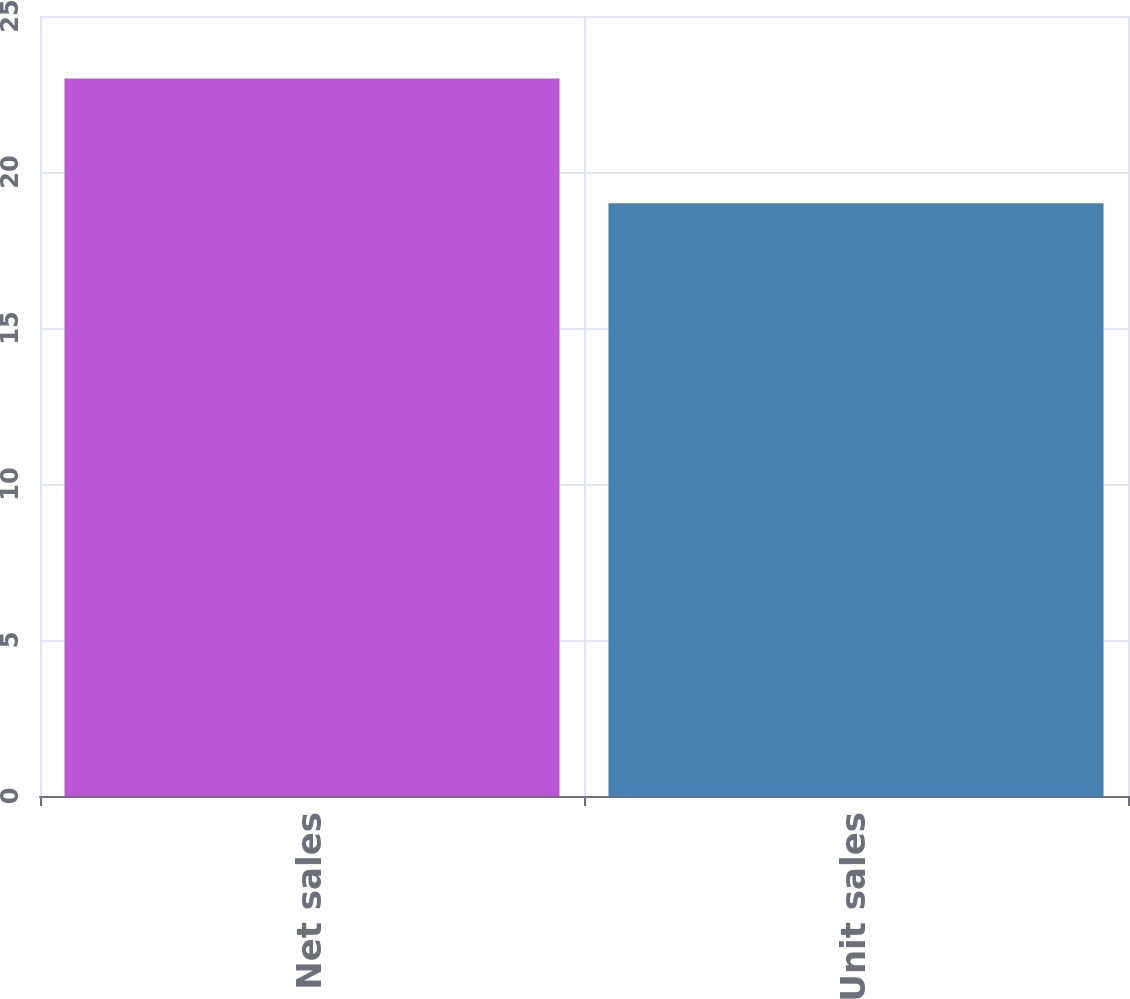Convert chart to OTSL. <chart><loc_0><loc_0><loc_500><loc_500><bar_chart><fcel>Net sales<fcel>Unit sales<nl><fcel>23<fcel>19<nl></chart> 